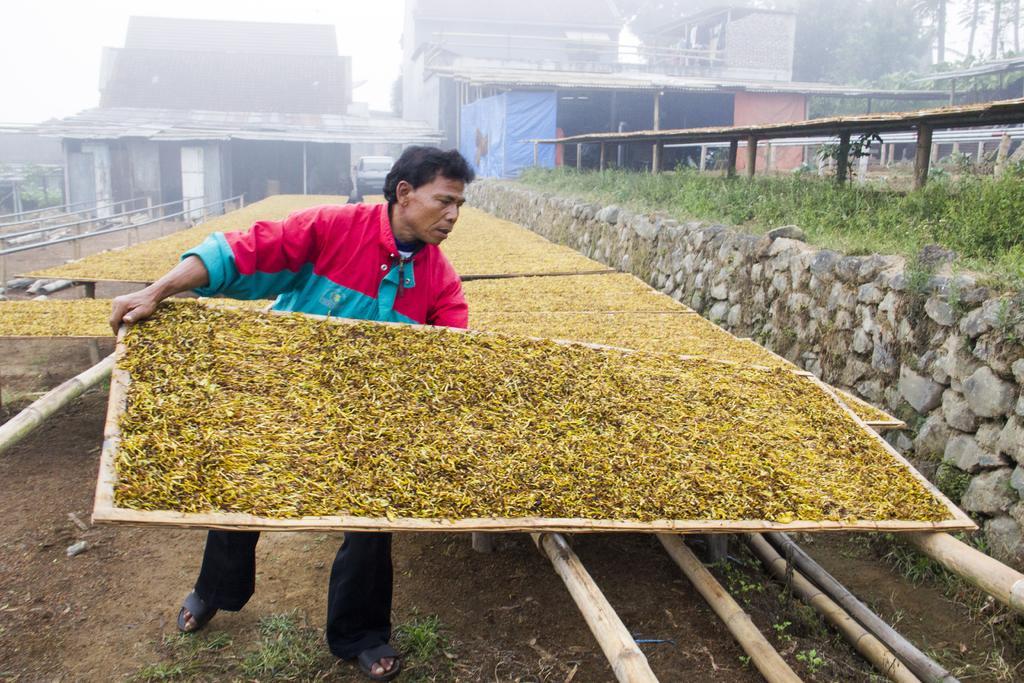How would you summarize this image in a sentence or two? In the center of the image we can see a man standing and holding a mat containing leaves. On the right there is a shed and grass. In the background there are mats, buildings and sky. At the bottom there are logs. 